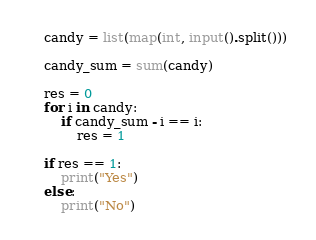<code> <loc_0><loc_0><loc_500><loc_500><_Python_>candy = list(map(int, input().split()))

candy_sum = sum(candy)

res = 0
for i in candy:
    if candy_sum - i == i:
        res = 1

if res == 1:
    print("Yes")
else:
    print("No")</code> 